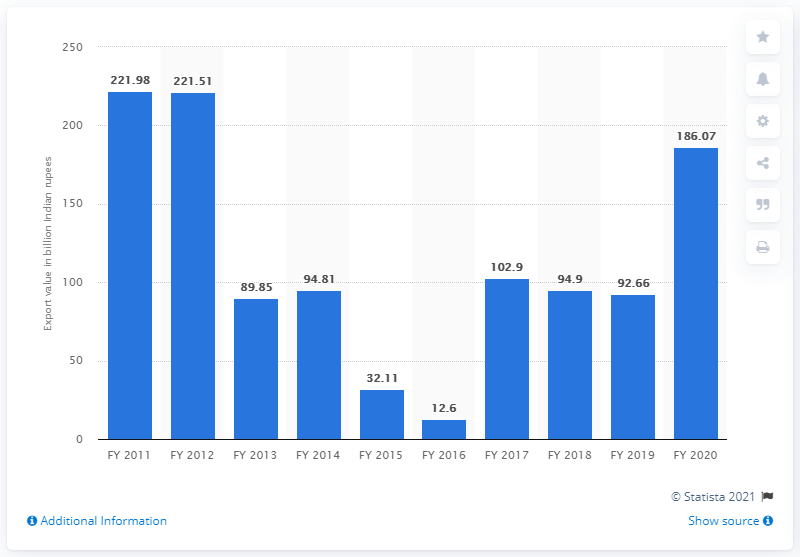Indicate a few pertinent items in this graphic. In the fiscal year 2020, the previous value of iron ore exported from India was 92.66 million metric tons. In the fiscal year 2020, the value of iron ore exported from India was 186.07 million units. 